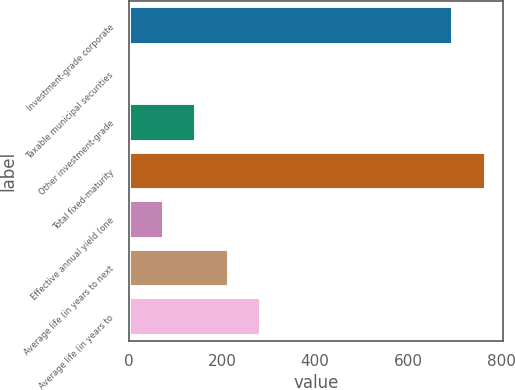<chart> <loc_0><loc_0><loc_500><loc_500><bar_chart><fcel>Investment-grade corporate<fcel>Taxable municipal securities<fcel>Other investment-grade<fcel>Total fixed-maturity<fcel>Effective annual yield (one<fcel>Average life (in years to next<fcel>Average life (in years to<nl><fcel>696.3<fcel>4.53<fcel>144.63<fcel>766.35<fcel>74.58<fcel>214.68<fcel>284.73<nl></chart> 